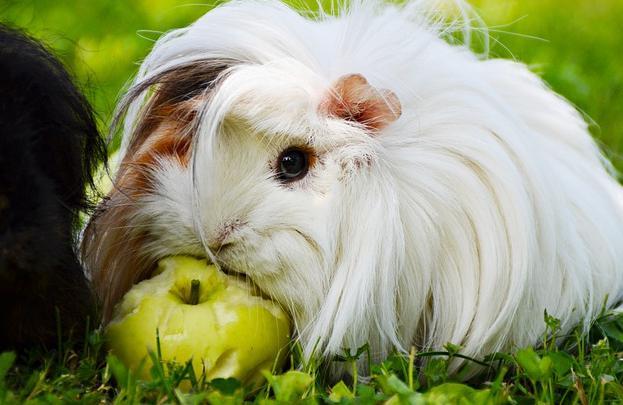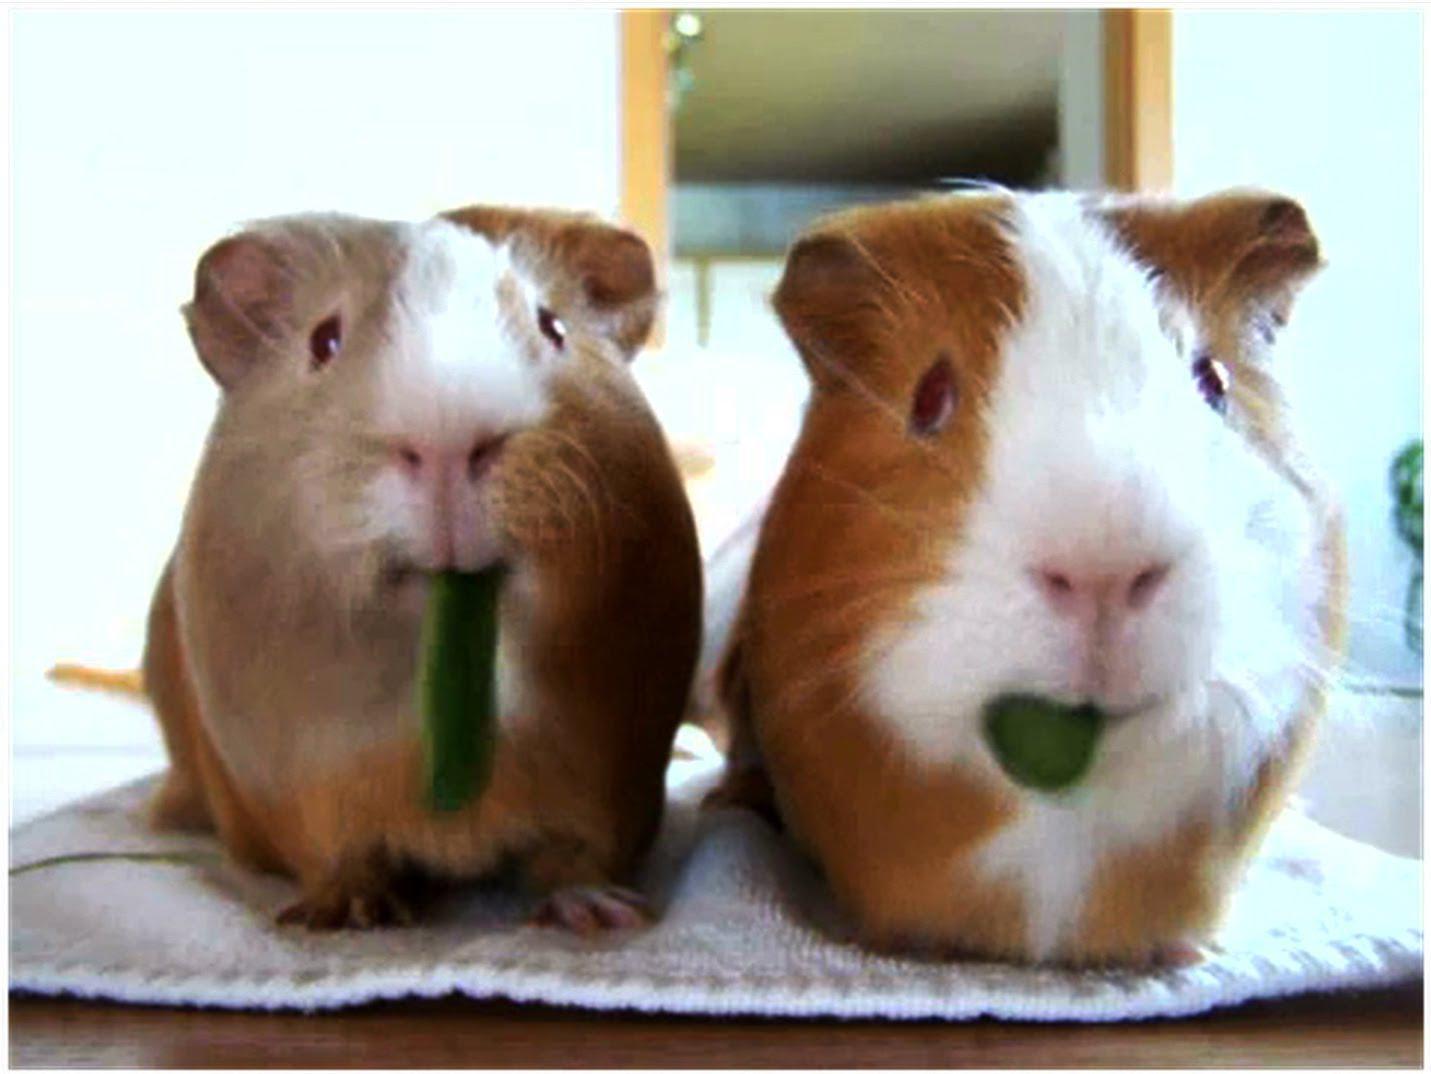The first image is the image on the left, the second image is the image on the right. Evaluate the accuracy of this statement regarding the images: "The right image contains exactly two rodents.". Is it true? Answer yes or no. Yes. The first image is the image on the left, the second image is the image on the right. Evaluate the accuracy of this statement regarding the images: "All guinea pigs are on green grass, and none of them are standing upright.". Is it true? Answer yes or no. No. 